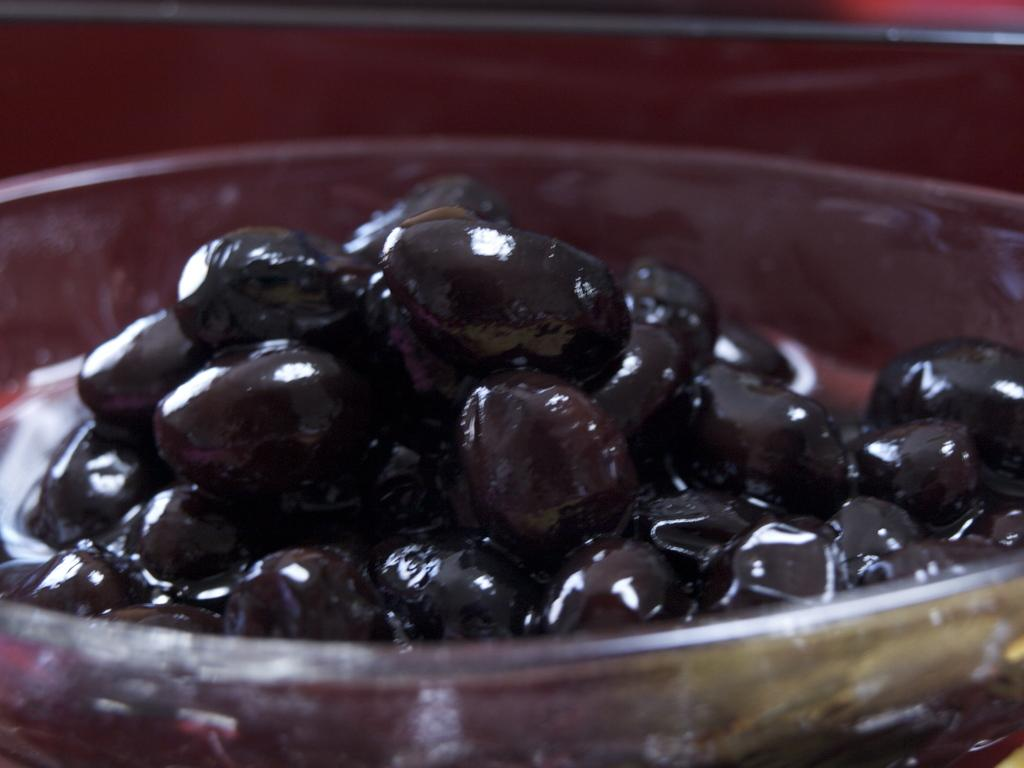What color are the fruits in the image? The fruits in the image are black. Where are the black fruits located? The black fruits are in a glass bowl. What type of honey can be seen dripping from the hill in the image? There is no honey or hill present in the image; it features black fruits in a glass bowl. 